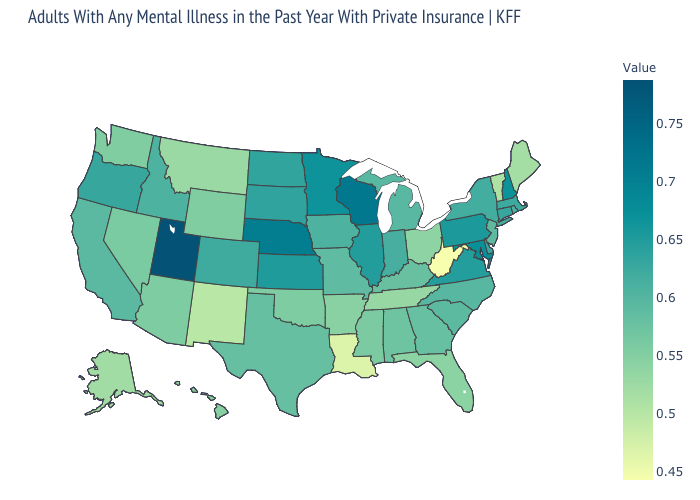Does Delaware have a higher value than Wisconsin?
Short answer required. No. Is the legend a continuous bar?
Keep it brief. Yes. Which states have the lowest value in the West?
Keep it brief. New Mexico. Among the states that border Rhode Island , which have the highest value?
Be succinct. Connecticut. Does Rhode Island have a lower value than Pennsylvania?
Write a very short answer. Yes. Which states have the lowest value in the South?
Quick response, please. West Virginia. 